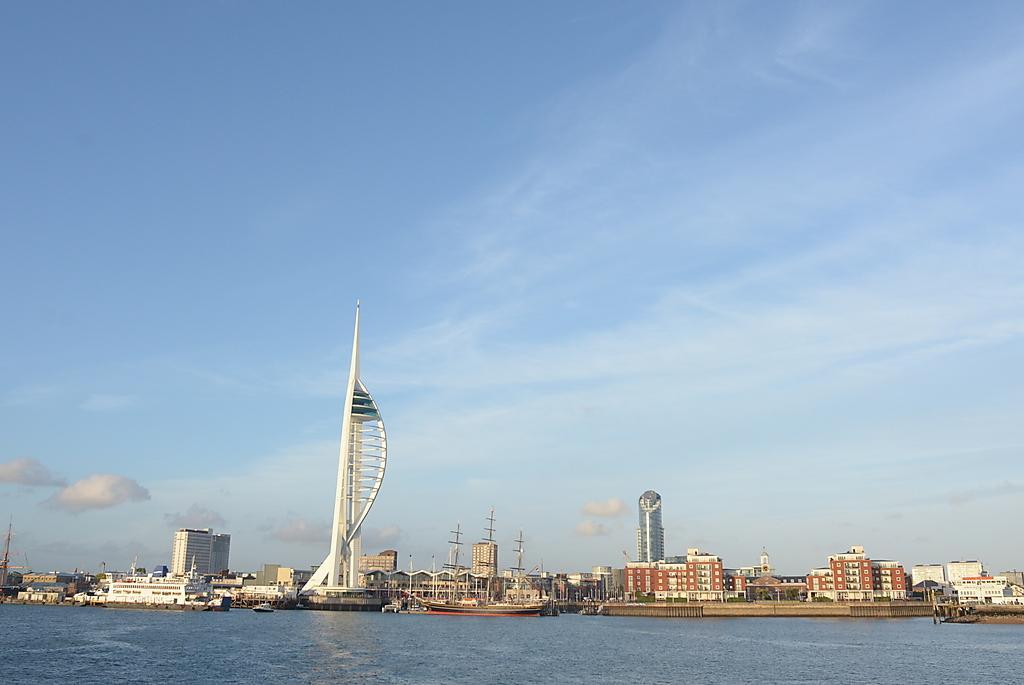Describe this image in one or two sentences. This image is clicked in an ocean. In the background, there are many buildings and skyscrapers. At the top, there are clouds in the sky. 